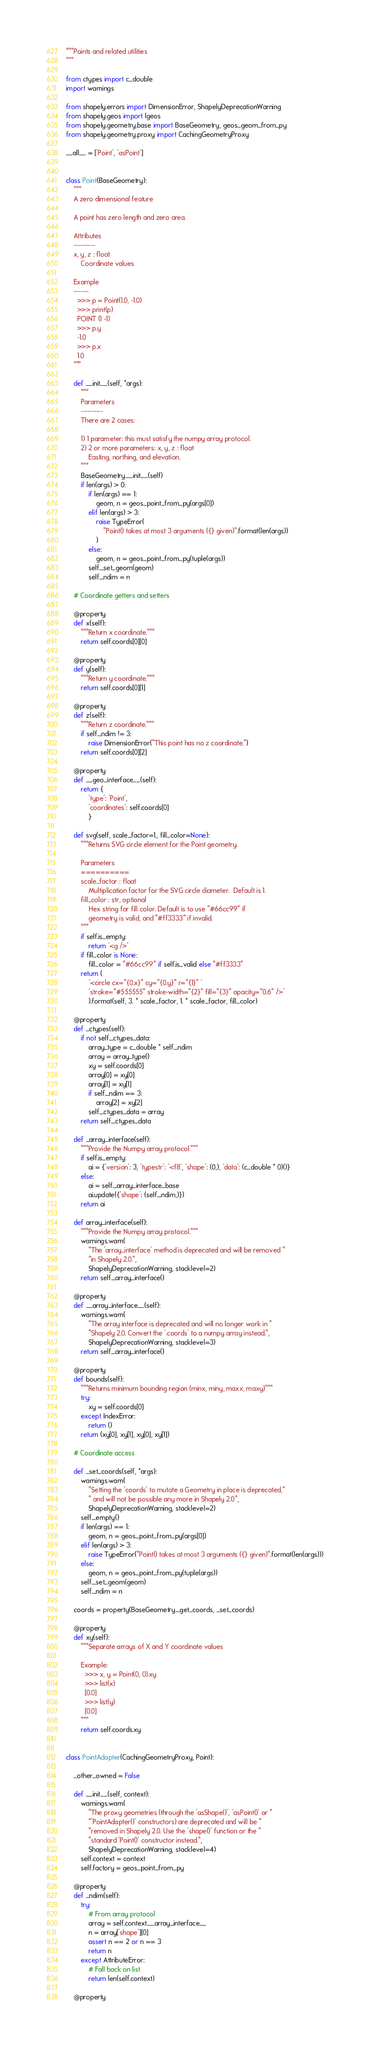Convert code to text. <code><loc_0><loc_0><loc_500><loc_500><_Python_>"""Points and related utilities
"""

from ctypes import c_double
import warnings

from shapely.errors import DimensionError, ShapelyDeprecationWarning
from shapely.geos import lgeos
from shapely.geometry.base import BaseGeometry, geos_geom_from_py
from shapely.geometry.proxy import CachingGeometryProxy

__all__ = ['Point', 'asPoint']


class Point(BaseGeometry):
    """
    A zero dimensional feature

    A point has zero length and zero area.

    Attributes
    ----------
    x, y, z : float
        Coordinate values

    Example
    -------
      >>> p = Point(1.0, -1.0)
      >>> print(p)
      POINT (1 -1)
      >>> p.y
      -1.0
      >>> p.x
      1.0
    """

    def __init__(self, *args):
        """
        Parameters
        ----------
        There are 2 cases:

        1) 1 parameter: this must satisfy the numpy array protocol.
        2) 2 or more parameters: x, y, z : float
            Easting, northing, and elevation.
        """
        BaseGeometry.__init__(self)
        if len(args) > 0:
            if len(args) == 1:
                geom, n = geos_point_from_py(args[0])
            elif len(args) > 3:
                raise TypeError(
                    "Point() takes at most 3 arguments ({} given)".format(len(args))
                )
            else:
                geom, n = geos_point_from_py(tuple(args))
            self._set_geom(geom)
            self._ndim = n

    # Coordinate getters and setters

    @property
    def x(self):
        """Return x coordinate."""
        return self.coords[0][0]

    @property
    def y(self):
        """Return y coordinate."""
        return self.coords[0][1]

    @property
    def z(self):
        """Return z coordinate."""
        if self._ndim != 3:
            raise DimensionError("This point has no z coordinate.")
        return self.coords[0][2]

    @property
    def __geo_interface__(self):
        return {
            'type': 'Point',
            'coordinates': self.coords[0]
            }

    def svg(self, scale_factor=1., fill_color=None):
        """Returns SVG circle element for the Point geometry.

        Parameters
        ==========
        scale_factor : float
            Multiplication factor for the SVG circle diameter.  Default is 1.
        fill_color : str, optional
            Hex string for fill color. Default is to use "#66cc99" if
            geometry is valid, and "#ff3333" if invalid.
        """
        if self.is_empty:
            return '<g />'
        if fill_color is None:
            fill_color = "#66cc99" if self.is_valid else "#ff3333"
        return (
            '<circle cx="{0.x}" cy="{0.y}" r="{1}" '
            'stroke="#555555" stroke-width="{2}" fill="{3}" opacity="0.6" />'
            ).format(self, 3. * scale_factor, 1. * scale_factor, fill_color)

    @property
    def _ctypes(self):
        if not self._ctypes_data:
            array_type = c_double * self._ndim
            array = array_type()
            xy = self.coords[0]
            array[0] = xy[0]
            array[1] = xy[1]
            if self._ndim == 3:
                array[2] = xy[2]
            self._ctypes_data = array
        return self._ctypes_data

    def _array_interface(self):
        """Provide the Numpy array protocol."""
        if self.is_empty:
            ai = {'version': 3, 'typestr': '<f8', 'shape': (0,), 'data': (c_double * 0)()}
        else:
            ai = self._array_interface_base
            ai.update({'shape': (self._ndim,)})
        return ai

    def array_interface(self):
        """Provide the Numpy array protocol."""
        warnings.warn(
            "The 'array_interface' method is deprecated and will be removed "
            "in Shapely 2.0.",
            ShapelyDeprecationWarning, stacklevel=2)
        return self._array_interface()

    @property
    def __array_interface__(self):
        warnings.warn(
            "The array interface is deprecated and will no longer work in "
            "Shapely 2.0. Convert the '.coords' to a numpy array instead.",
            ShapelyDeprecationWarning, stacklevel=3)
        return self._array_interface()

    @property
    def bounds(self):
        """Returns minimum bounding region (minx, miny, maxx, maxy)"""
        try:
            xy = self.coords[0]
        except IndexError:
            return ()
        return (xy[0], xy[1], xy[0], xy[1])

    # Coordinate access

    def _set_coords(self, *args):
        warnings.warn(
            "Setting the 'coords' to mutate a Geometry in place is deprecated,"
            " and will not be possible any more in Shapely 2.0",
            ShapelyDeprecationWarning, stacklevel=2)
        self._empty()
        if len(args) == 1:
            geom, n = geos_point_from_py(args[0])
        elif len(args) > 3:
            raise TypeError("Point() takes at most 3 arguments ({} given)".format(len(args)))
        else:
            geom, n = geos_point_from_py(tuple(args))
        self._set_geom(geom)
        self._ndim = n

    coords = property(BaseGeometry._get_coords, _set_coords)

    @property
    def xy(self):
        """Separate arrays of X and Y coordinate values

        Example:
          >>> x, y = Point(0, 0).xy
          >>> list(x)
          [0.0]
          >>> list(y)
          [0.0]
        """
        return self.coords.xy


class PointAdapter(CachingGeometryProxy, Point):

    _other_owned = False

    def __init__(self, context):
        warnings.warn(
            "The proxy geometries (through the 'asShape()', 'asPoint()' or "
            "'PointAdapter()' constructors) are deprecated and will be "
            "removed in Shapely 2.0. Use the 'shape()' function or the "
            "standard 'Point()' constructor instead.",
            ShapelyDeprecationWarning, stacklevel=4)
        self.context = context
        self.factory = geos_point_from_py

    @property
    def _ndim(self):
        try:
            # From array protocol
            array = self.context.__array_interface__
            n = array['shape'][0]
            assert n == 2 or n == 3
            return n
        except AttributeError:
            # Fall back on list
            return len(self.context)

    @property</code> 